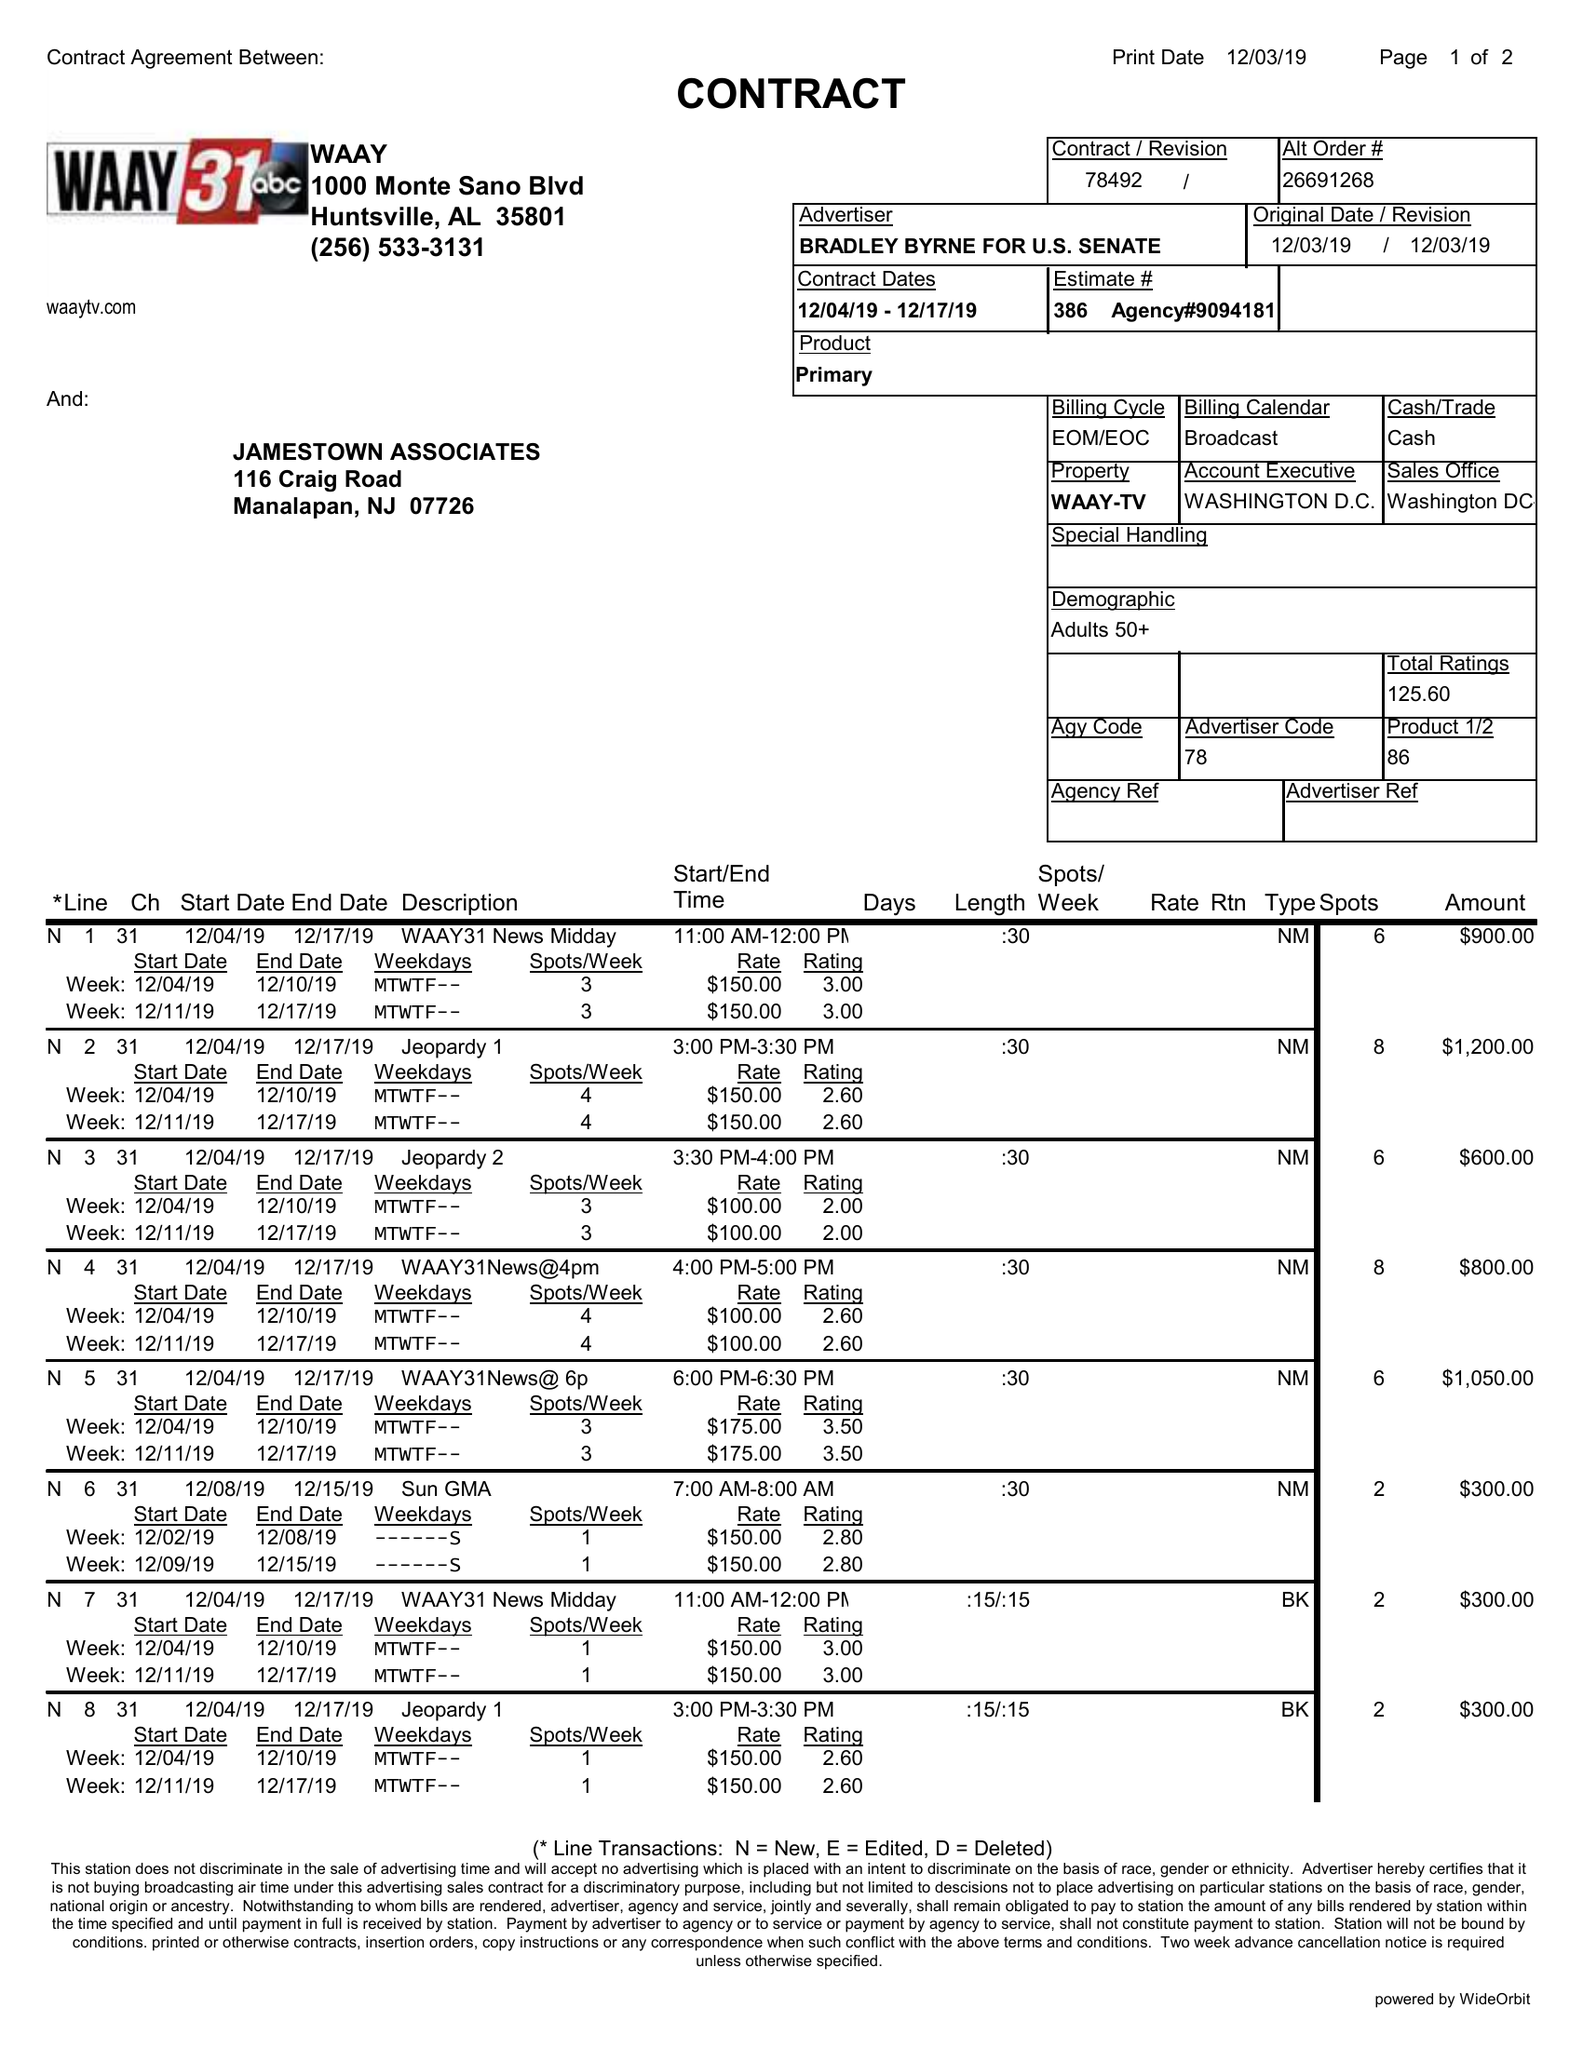What is the value for the flight_to?
Answer the question using a single word or phrase. 12/17/19 